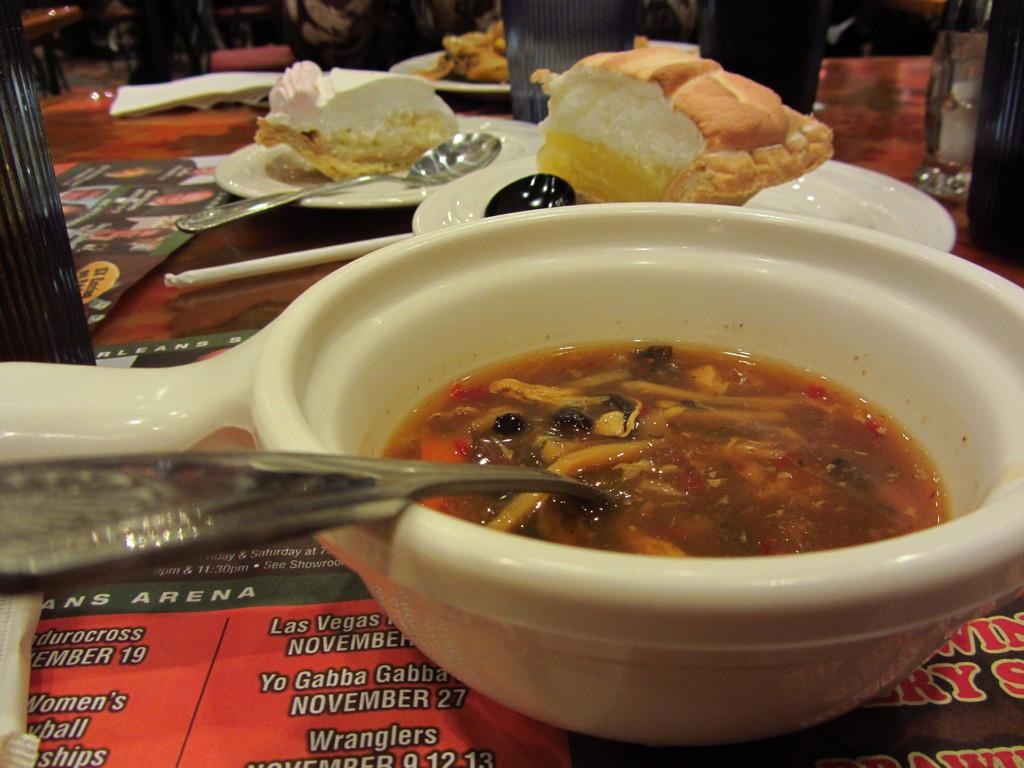What is the main subject in the center of the image? There is food in the center of the image. What utensils are present on the table? There are spoons on the table. What type of containers can be seen in the image? There are glasses in the image. What additional items are present in the image? There are papers in the image. What type of plant is growing in the center of the image? There is no plant growing in the center of the image; it is occupied by food. 